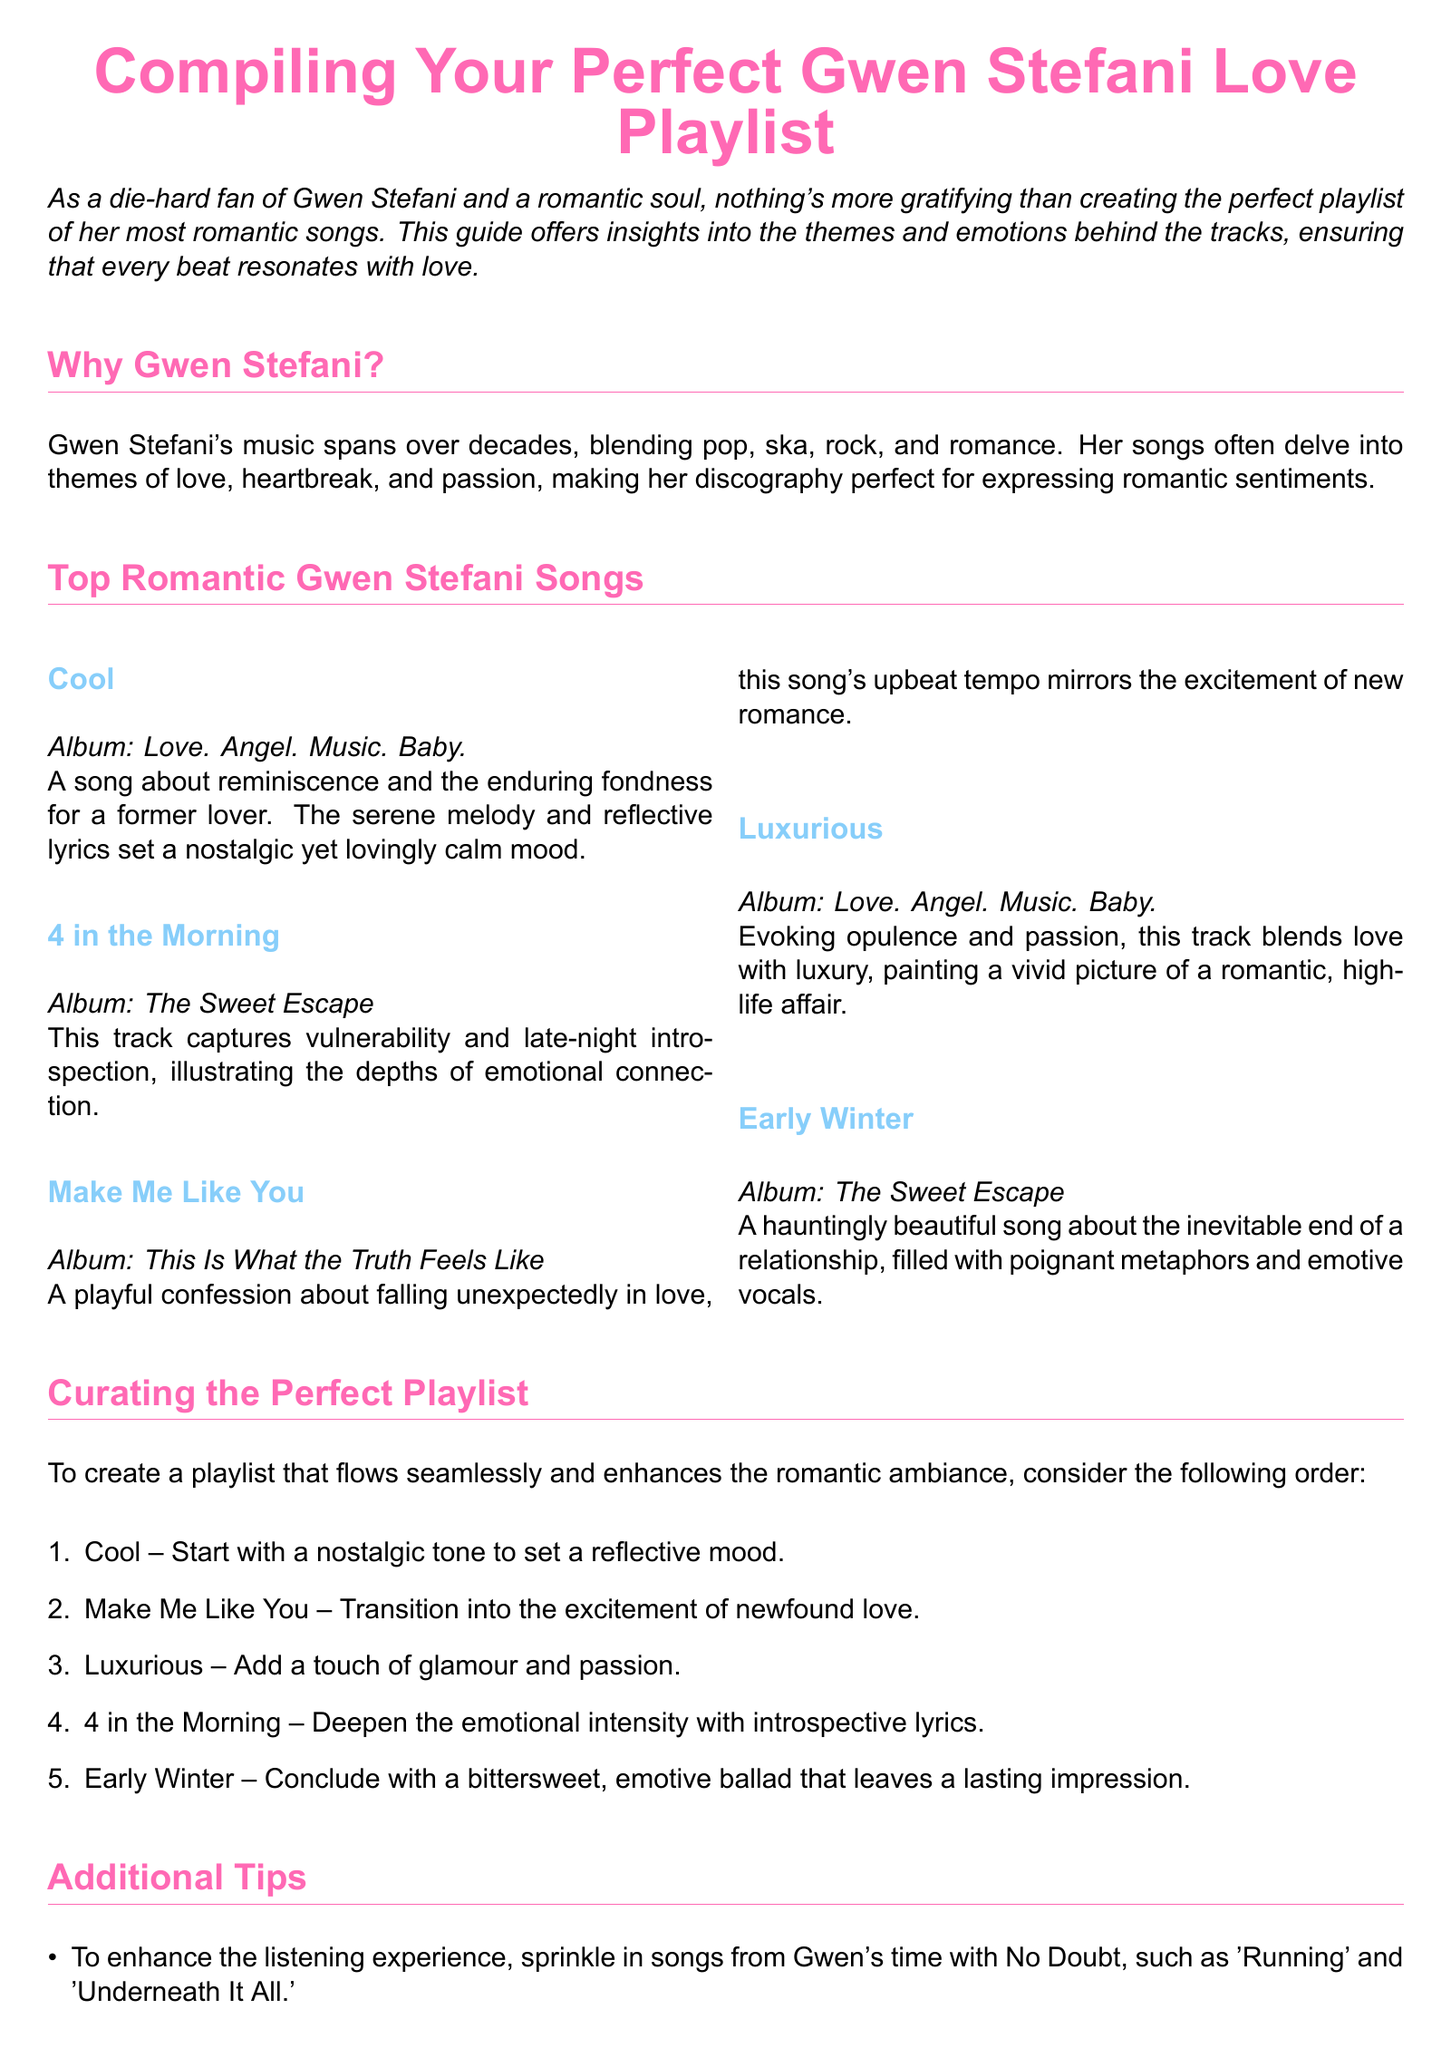What is the title of the guide? The title is explicitly stated at the beginning of the document.
Answer: Compiling Your Perfect Gwen Stefani Love Playlist How many top romantic songs are listed? The document explicitly counts the entries under the top romantic songs section.
Answer: Five What is the first song recommended in the playlist? The document outlines the suggested order of the playlist starting with the first song mentioned.
Answer: Cool Which album features the song "4 in the Morning"? The song is associated with its respective album mentioned in the document.
Answer: The Sweet Escape What theme does the song "Make Me Like You" express? The document describes the themes of the songs, including this one.
Answer: Falling unexpectedly in love What is suggested to sprinkle in for enhancing the playlist? The additional tips section suggests adding songs from Gwen's previous band.
Answer: Songs from No Doubt What emotional tone does the song "Early Winter" convey? The document describes the emotion expressed in the song.
Answer: Bittersweet How many songs are suggested for curating the perfect playlist order? The document outlines a specific number of songs in the suggested order.
Answer: Five 